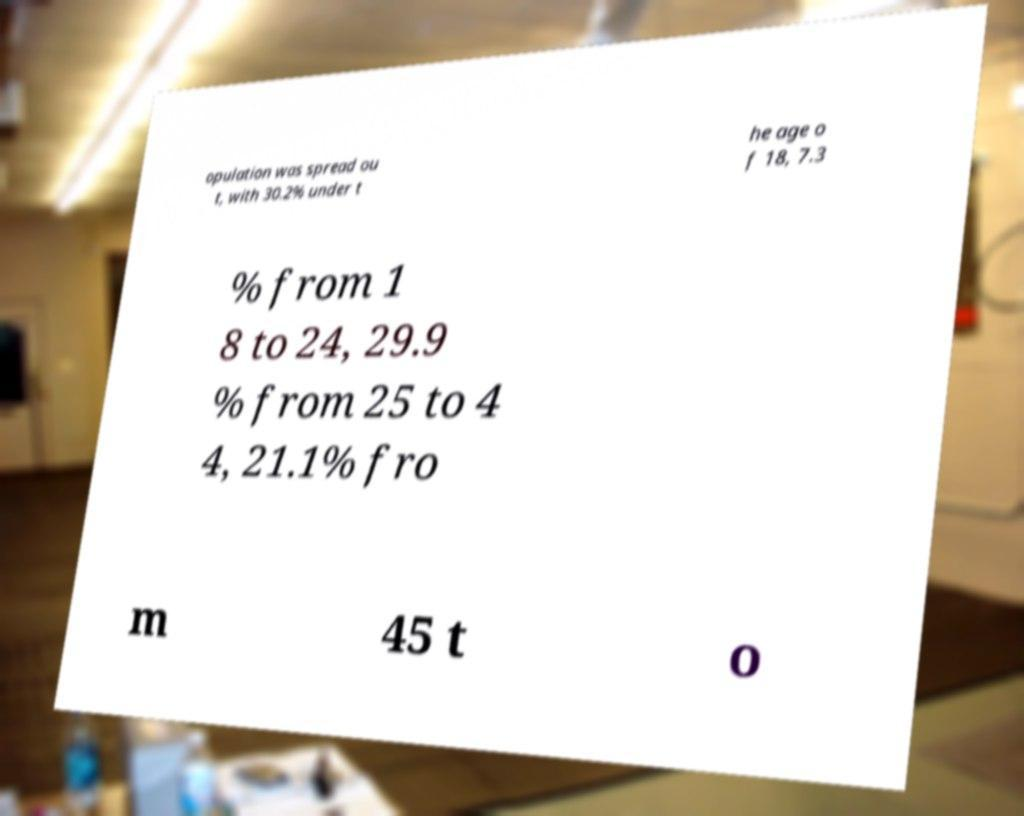Could you assist in decoding the text presented in this image and type it out clearly? opulation was spread ou t, with 30.2% under t he age o f 18, 7.3 % from 1 8 to 24, 29.9 % from 25 to 4 4, 21.1% fro m 45 t o 